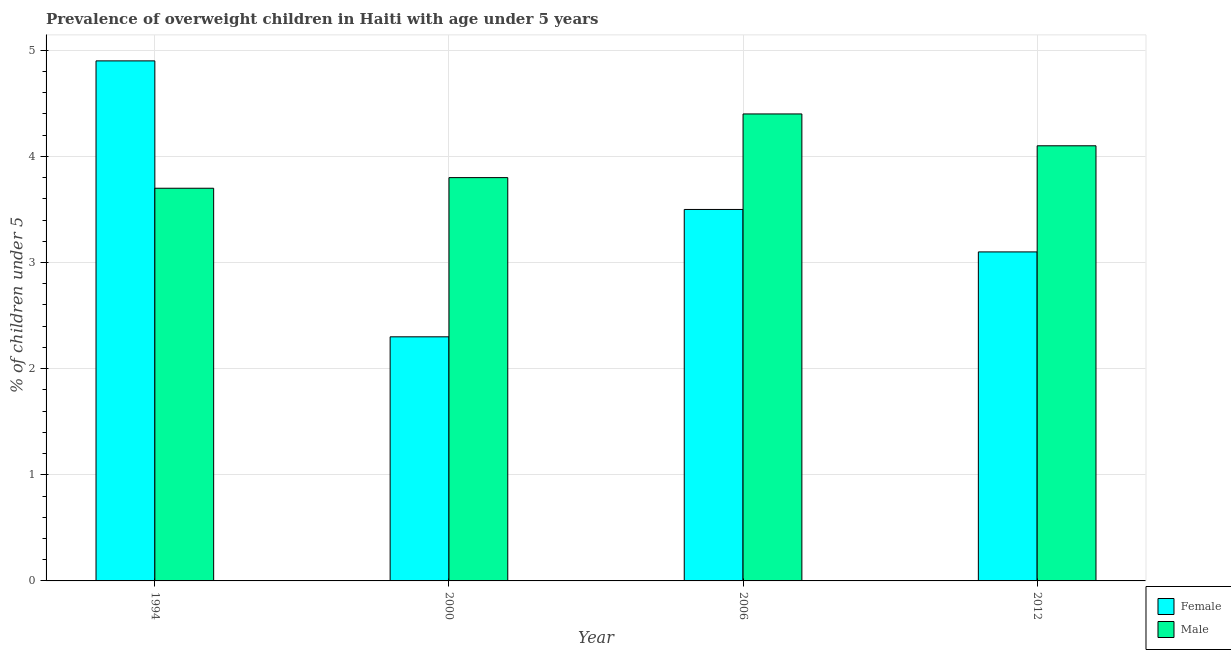How many different coloured bars are there?
Your answer should be very brief. 2. How many bars are there on the 4th tick from the left?
Provide a short and direct response. 2. In how many cases, is the number of bars for a given year not equal to the number of legend labels?
Provide a short and direct response. 0. What is the percentage of obese female children in 1994?
Give a very brief answer. 4.9. Across all years, what is the maximum percentage of obese female children?
Offer a very short reply. 4.9. Across all years, what is the minimum percentage of obese male children?
Provide a succinct answer. 3.7. What is the total percentage of obese female children in the graph?
Make the answer very short. 13.8. What is the difference between the percentage of obese male children in 2000 and that in 2012?
Your answer should be compact. -0.3. What is the difference between the percentage of obese male children in 2012 and the percentage of obese female children in 2006?
Provide a succinct answer. -0.3. What is the average percentage of obese female children per year?
Your response must be concise. 3.45. In the year 2006, what is the difference between the percentage of obese female children and percentage of obese male children?
Give a very brief answer. 0. In how many years, is the percentage of obese male children greater than 1.4 %?
Provide a short and direct response. 4. What is the ratio of the percentage of obese female children in 2000 to that in 2012?
Provide a succinct answer. 0.74. What is the difference between the highest and the second highest percentage of obese female children?
Provide a short and direct response. 1.4. What is the difference between the highest and the lowest percentage of obese female children?
Ensure brevity in your answer.  2.6. Is the sum of the percentage of obese female children in 1994 and 2012 greater than the maximum percentage of obese male children across all years?
Keep it short and to the point. Yes. What does the 2nd bar from the left in 1994 represents?
Offer a very short reply. Male. What does the 2nd bar from the right in 2012 represents?
Give a very brief answer. Female. Are all the bars in the graph horizontal?
Give a very brief answer. No. How many years are there in the graph?
Provide a succinct answer. 4. What is the difference between two consecutive major ticks on the Y-axis?
Provide a succinct answer. 1. Does the graph contain any zero values?
Give a very brief answer. No. Where does the legend appear in the graph?
Your answer should be compact. Bottom right. What is the title of the graph?
Offer a terse response. Prevalence of overweight children in Haiti with age under 5 years. What is the label or title of the Y-axis?
Your response must be concise.  % of children under 5. What is the  % of children under 5 in Female in 1994?
Give a very brief answer. 4.9. What is the  % of children under 5 of Male in 1994?
Provide a short and direct response. 3.7. What is the  % of children under 5 of Female in 2000?
Your response must be concise. 2.3. What is the  % of children under 5 of Male in 2000?
Provide a short and direct response. 3.8. What is the  % of children under 5 in Male in 2006?
Ensure brevity in your answer.  4.4. What is the  % of children under 5 in Female in 2012?
Provide a succinct answer. 3.1. What is the  % of children under 5 in Male in 2012?
Your answer should be compact. 4.1. Across all years, what is the maximum  % of children under 5 of Female?
Your answer should be compact. 4.9. Across all years, what is the maximum  % of children under 5 in Male?
Keep it short and to the point. 4.4. Across all years, what is the minimum  % of children under 5 in Female?
Keep it short and to the point. 2.3. Across all years, what is the minimum  % of children under 5 of Male?
Make the answer very short. 3.7. What is the difference between the  % of children under 5 of Female in 1994 and that in 2000?
Provide a succinct answer. 2.6. What is the difference between the  % of children under 5 of Female in 1994 and that in 2006?
Make the answer very short. 1.4. What is the difference between the  % of children under 5 in Male in 1994 and that in 2006?
Give a very brief answer. -0.7. What is the difference between the  % of children under 5 of Male in 1994 and that in 2012?
Provide a short and direct response. -0.4. What is the difference between the  % of children under 5 in Female in 2000 and that in 2006?
Make the answer very short. -1.2. What is the difference between the  % of children under 5 of Male in 2000 and that in 2006?
Your response must be concise. -0.6. What is the difference between the  % of children under 5 in Female in 2000 and that in 2012?
Give a very brief answer. -0.8. What is the difference between the  % of children under 5 of Female in 2006 and that in 2012?
Offer a very short reply. 0.4. What is the difference between the  % of children under 5 of Female in 1994 and the  % of children under 5 of Male in 2006?
Provide a short and direct response. 0.5. What is the difference between the  % of children under 5 in Female in 1994 and the  % of children under 5 in Male in 2012?
Offer a terse response. 0.8. What is the difference between the  % of children under 5 in Female in 2006 and the  % of children under 5 in Male in 2012?
Your answer should be very brief. -0.6. What is the average  % of children under 5 in Female per year?
Provide a succinct answer. 3.45. In the year 2000, what is the difference between the  % of children under 5 in Female and  % of children under 5 in Male?
Provide a succinct answer. -1.5. In the year 2012, what is the difference between the  % of children under 5 of Female and  % of children under 5 of Male?
Keep it short and to the point. -1. What is the ratio of the  % of children under 5 of Female in 1994 to that in 2000?
Offer a very short reply. 2.13. What is the ratio of the  % of children under 5 in Male in 1994 to that in 2000?
Offer a very short reply. 0.97. What is the ratio of the  % of children under 5 of Male in 1994 to that in 2006?
Your answer should be very brief. 0.84. What is the ratio of the  % of children under 5 in Female in 1994 to that in 2012?
Ensure brevity in your answer.  1.58. What is the ratio of the  % of children under 5 in Male in 1994 to that in 2012?
Ensure brevity in your answer.  0.9. What is the ratio of the  % of children under 5 of Female in 2000 to that in 2006?
Your answer should be very brief. 0.66. What is the ratio of the  % of children under 5 of Male in 2000 to that in 2006?
Provide a succinct answer. 0.86. What is the ratio of the  % of children under 5 in Female in 2000 to that in 2012?
Ensure brevity in your answer.  0.74. What is the ratio of the  % of children under 5 of Male in 2000 to that in 2012?
Your answer should be very brief. 0.93. What is the ratio of the  % of children under 5 in Female in 2006 to that in 2012?
Ensure brevity in your answer.  1.13. What is the ratio of the  % of children under 5 of Male in 2006 to that in 2012?
Provide a succinct answer. 1.07. What is the difference between the highest and the second highest  % of children under 5 in Male?
Your response must be concise. 0.3. What is the difference between the highest and the lowest  % of children under 5 of Male?
Your answer should be very brief. 0.7. 